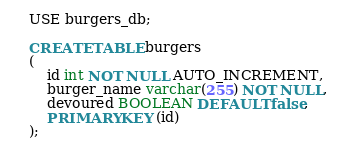<code> <loc_0><loc_0><loc_500><loc_500><_SQL_>USE burgers_db;

CREATE TABLE burgers
(
	id int NOT NULL AUTO_INCREMENT,
	burger_name varchar(255) NOT NULL,
	devoured BOOLEAN DEFAULT false,
	PRIMARY KEY (id)
);</code> 